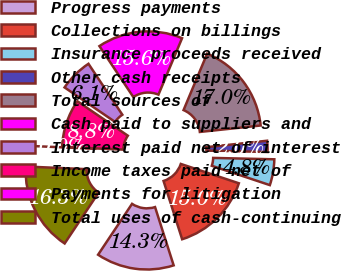Convert chart to OTSL. <chart><loc_0><loc_0><loc_500><loc_500><pie_chart><fcel>Progress payments<fcel>Collections on billings<fcel>Insurance proceeds received<fcel>Other cash receipts<fcel>Total sources of<fcel>Cash paid to suppliers and<fcel>Interest paid net of interest<fcel>Income taxes paid net of<fcel>Payments for litigation<fcel>Total uses of cash-continuing<nl><fcel>14.28%<fcel>14.96%<fcel>4.76%<fcel>2.04%<fcel>17.01%<fcel>15.64%<fcel>6.12%<fcel>8.84%<fcel>0.0%<fcel>16.32%<nl></chart> 